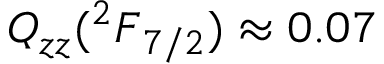Convert formula to latex. <formula><loc_0><loc_0><loc_500><loc_500>{ Q _ { z z } ( { ^ { 2 } F } _ { 7 / 2 } ) \approx 0 . 0 7 }</formula> 